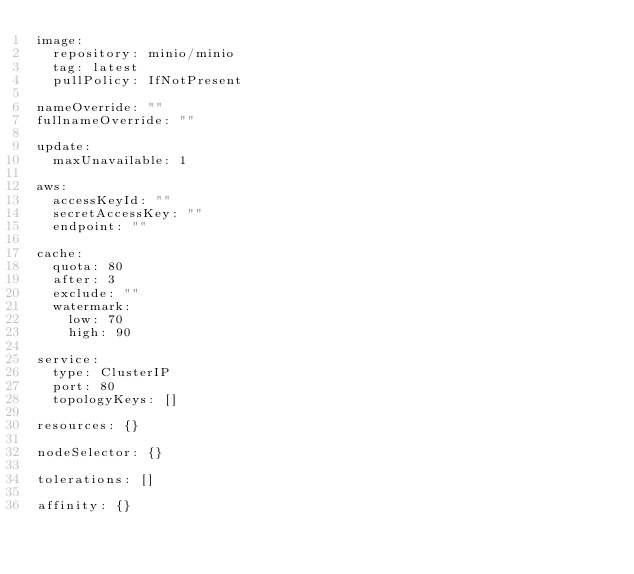Convert code to text. <code><loc_0><loc_0><loc_500><loc_500><_YAML_>image:
  repository: minio/minio
  tag: latest
  pullPolicy: IfNotPresent

nameOverride: ""
fullnameOverride: ""

update:
  maxUnavailable: 1

aws:
  accessKeyId: ""
  secretAccessKey: ""
  endpoint: ""

cache:
  quota: 80
  after: 3
  exclude: ""
  watermark:
    low: 70
    high: 90

service:
  type: ClusterIP
  port: 80
  topologyKeys: []

resources: {}

nodeSelector: {}

tolerations: []

affinity: {}</code> 